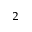<formula> <loc_0><loc_0><loc_500><loc_500>_ { 2 }</formula> 